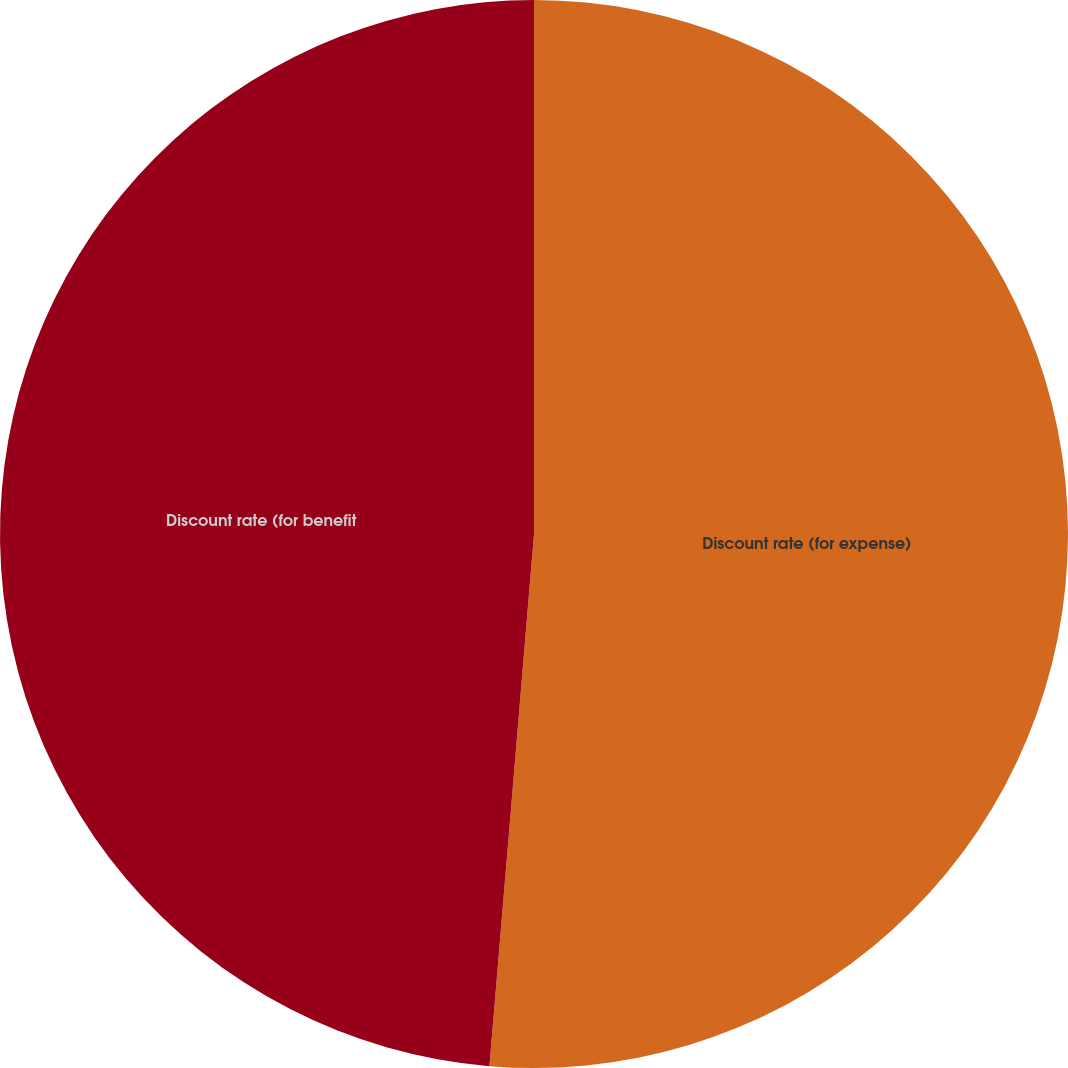Convert chart to OTSL. <chart><loc_0><loc_0><loc_500><loc_500><pie_chart><fcel>Discount rate (for expense)<fcel>Discount rate (for benefit<nl><fcel>51.33%<fcel>48.67%<nl></chart> 